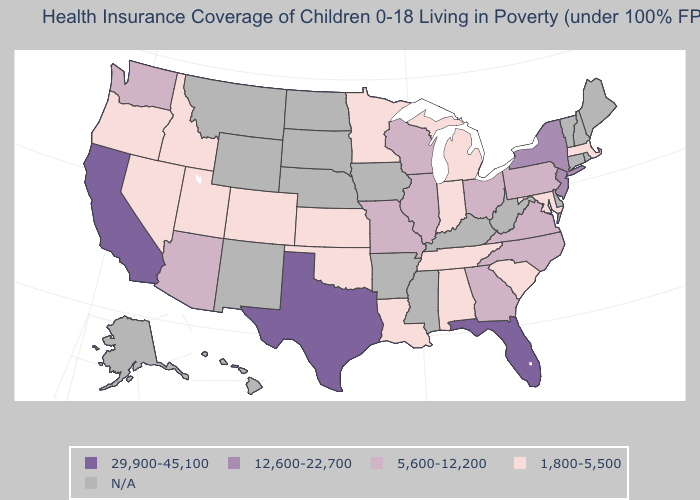What is the lowest value in the USA?
Be succinct. 1,800-5,500. Name the states that have a value in the range 1,800-5,500?
Keep it brief. Alabama, Colorado, Idaho, Indiana, Kansas, Louisiana, Maryland, Massachusetts, Michigan, Minnesota, Nevada, Oklahoma, Oregon, South Carolina, Tennessee, Utah. What is the lowest value in states that border Nevada?
Write a very short answer. 1,800-5,500. What is the value of Michigan?
Give a very brief answer. 1,800-5,500. What is the lowest value in the USA?
Short answer required. 1,800-5,500. Does Oklahoma have the highest value in the USA?
Write a very short answer. No. Does the map have missing data?
Be succinct. Yes. Which states have the lowest value in the West?
Be succinct. Colorado, Idaho, Nevada, Oregon, Utah. Does the map have missing data?
Keep it brief. Yes. Name the states that have a value in the range 29,900-45,100?
Quick response, please. California, Florida, Texas. What is the lowest value in the West?
Be succinct. 1,800-5,500. What is the value of Wisconsin?
Write a very short answer. 5,600-12,200. What is the lowest value in the South?
Answer briefly. 1,800-5,500. Name the states that have a value in the range 1,800-5,500?
Concise answer only. Alabama, Colorado, Idaho, Indiana, Kansas, Louisiana, Maryland, Massachusetts, Michigan, Minnesota, Nevada, Oklahoma, Oregon, South Carolina, Tennessee, Utah. 